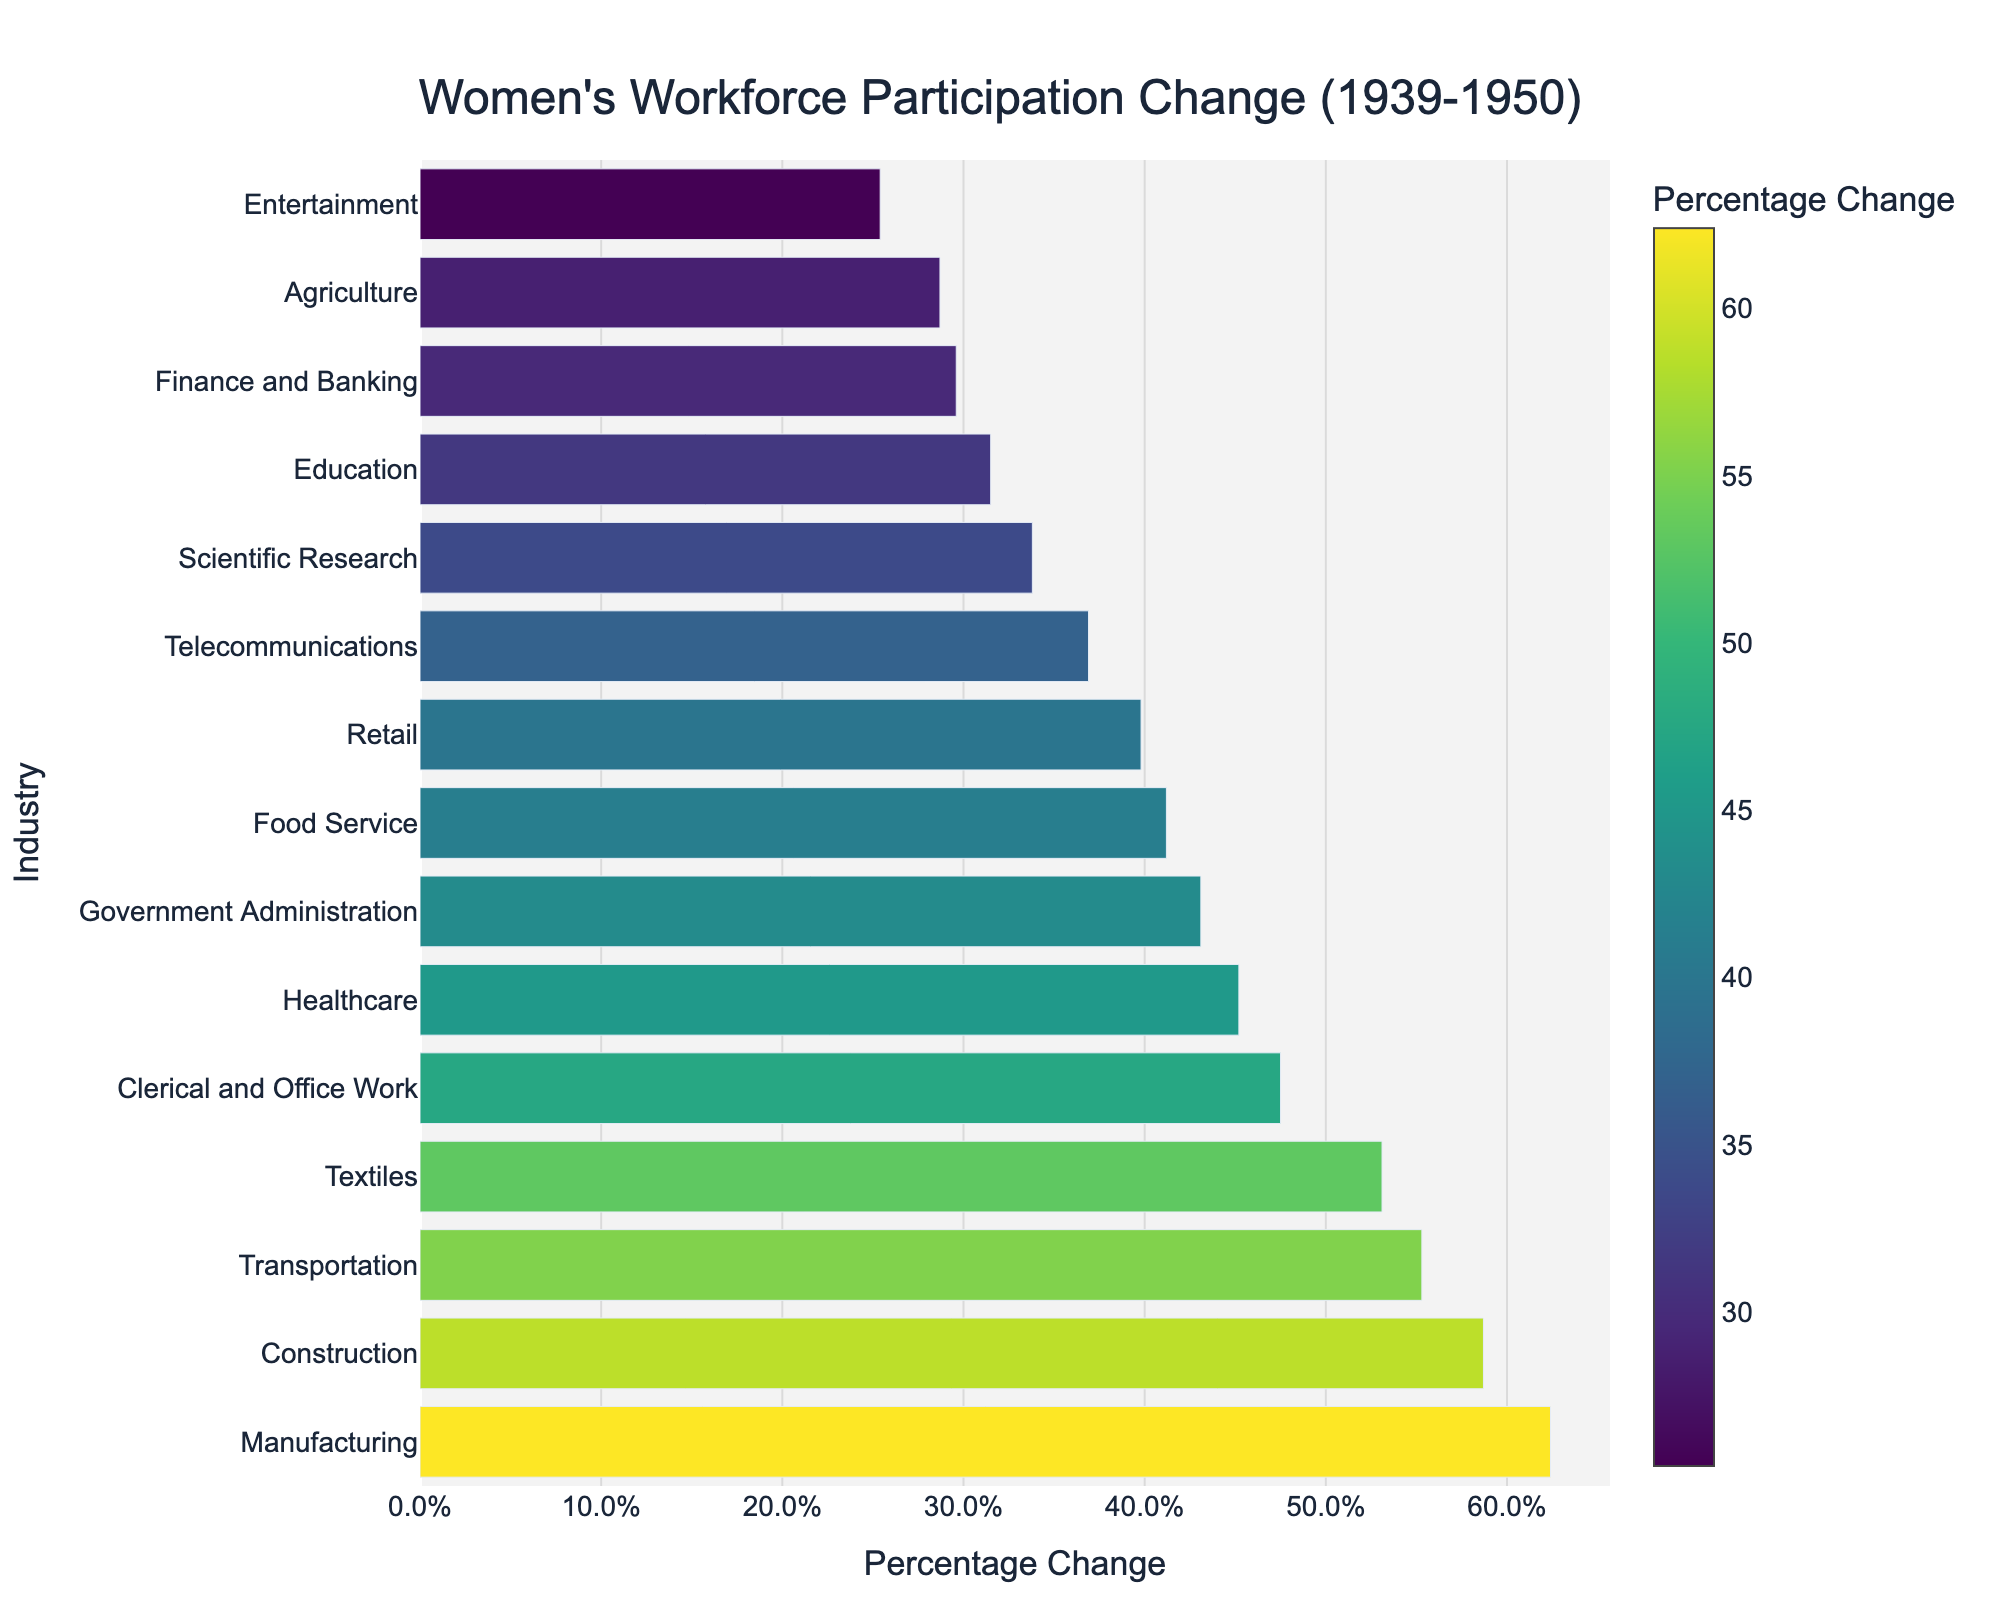Which industry experienced the highest percentage change in women's workforce participation between 1939 and 1950? The bar chart shows varying percentage changes for different industries. By comparing the heights of the bars, we can see that Manufacturing has the highest percentage change.
Answer: Manufacturing Which two industries had a percentage change in women's workforce participation above 50%, and what are the values? By observing the lengths of the bars, we can identify Manufacturing (62.4%) and Construction (58.7%) as the industries with percentage changes above 50%.
Answer: Manufacturing: 62.4%, Construction: 58.7% What is the difference in percentage change between Telecommunications and Retail? From the figure, we find that Telecommunications has a change of 36.9% and Retail has a change of 39.8%. The difference is calculated as 39.8% - 36.9% = 2.9%.
Answer: 2.9% How many industries saw a percentage change in women's workforce participation of 40% or more? By counting the bars that reach or exceed the 40% mark on the x-axis, we find that there are 8 industries meeting this criterion: Manufacturing, Construction, Transportation, Textiles, Clerical and Office Work, Healthcare, Food Service, and Retail.
Answer: 8 Which industry had the lowest percentage change, and what is the value? By comparing the bars, Entertainment is the shortest, indicating the lowest percentage change at 25.4%.
Answer: Entertainment: 25.4% What is the average percentage change of the top three industries? The top three industries by percentage change are Manufacturing (62.4%), Construction (58.7%), and Transportation (55.3%). The average is calculated as (62.4 + 58.7 + 55.3) / 3 = 58.8%.
Answer: 58.8% How does the percentage change in Clerical and Office Work compare to that in Government Administration? From the chart, Clerical and Office Work has a change of 47.5% while Government Administration has 43.1%. Clerical and Office Work’s change is greater by 4.4%.
Answer: Clerical and Office Work is greater by 4.4% Which industry has a percentage change closest to the median change of all the industries? To find the median, we list the percentage changes in ascending order: 25.4%, 28.7%, 29.6%, 31.5%, 33.8%, 36.9%, 39.8%, 41.2%, 43.1%, 45.2%, 47.5%, 53.1%, 55.3%, 58.7%, 62.4%. With 15 values, the median is the 8th value, which is Retail with 39.8%.
Answer: Retail: 39.8% What is the combined percentage change for Agriculture and Scientific Research industries? The changes for Agriculture and Scientific Research are 28.7% and 33.8%, respectively. Combined, this totals 28.7% + 33.8% = 62.5%.
Answer: 62.5% What percentage change does Healthcare have, and how does it visually compare to Food Service on the chart? The Healthcare bar shows a change of 45.2%, and the Food Service bar shows 41.2%. Visually, the Healthcare bar is slightly longer than that of Food Service.
Answer: Healthcare: 45.2%, slightly longer than Food Service 